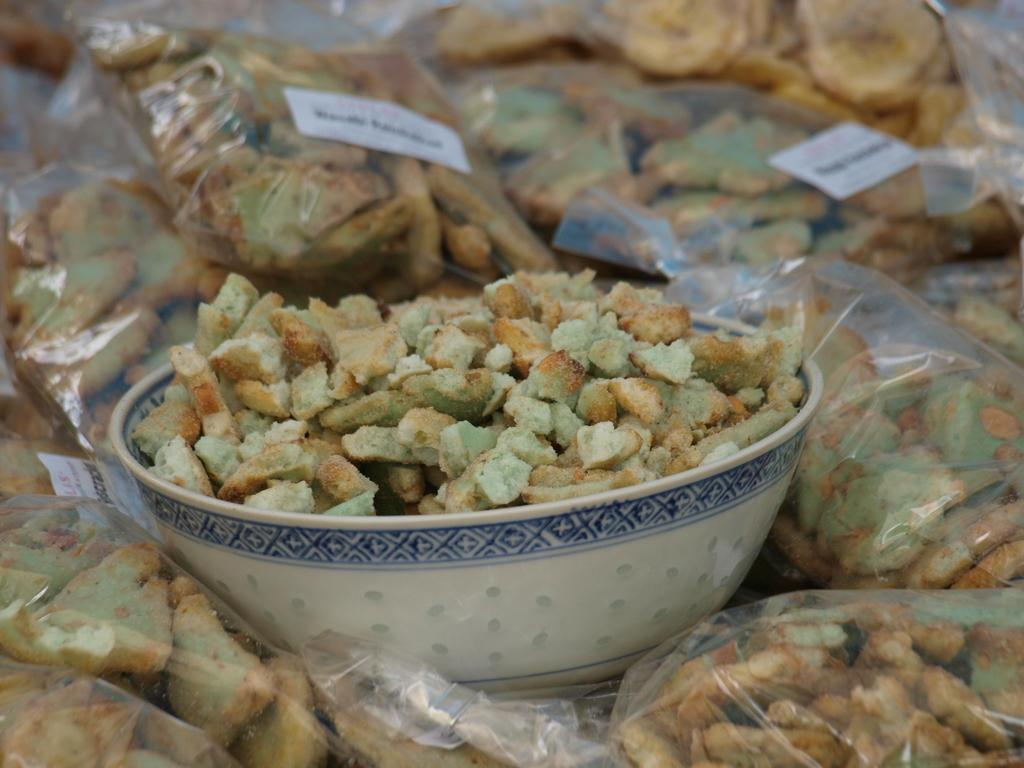What is in the image that can hold food? There is a bowl in the image that can hold food. What type of food containers are visible in the image? There are food packets in the image. What type of food can be seen in the image? There is food in the image. What color is the person's toe in the image? There are no people or body parts visible in the image, so it is not possible to determine the color of anyone's toe. 